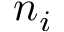<formula> <loc_0><loc_0><loc_500><loc_500>n _ { i }</formula> 